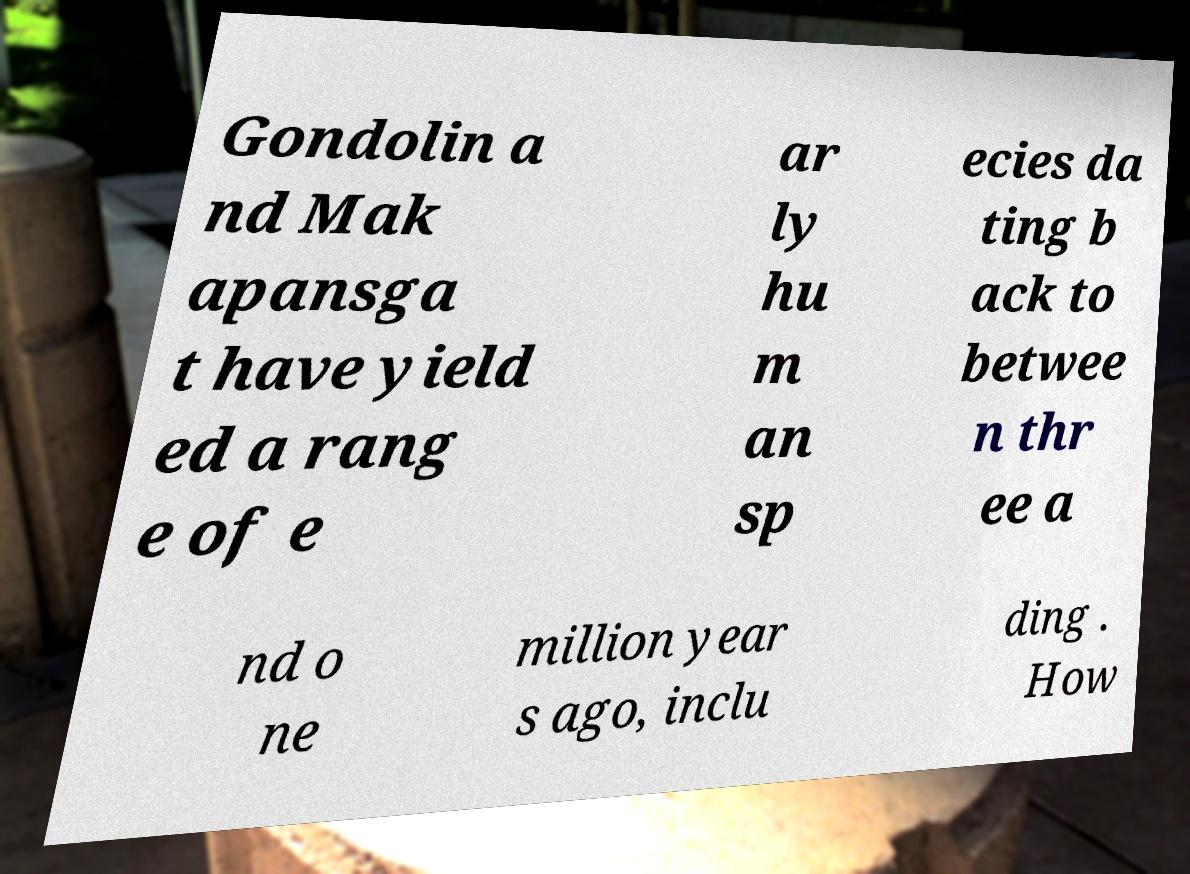What messages or text are displayed in this image? I need them in a readable, typed format. Gondolin a nd Mak apansga t have yield ed a rang e of e ar ly hu m an sp ecies da ting b ack to betwee n thr ee a nd o ne million year s ago, inclu ding . How 